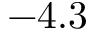<formula> <loc_0><loc_0><loc_500><loc_500>- 4 . 3</formula> 